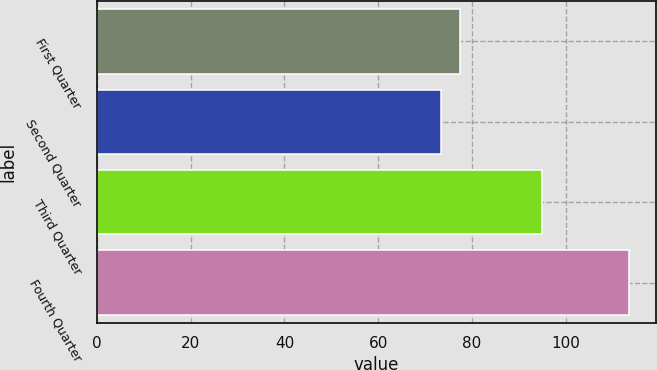Convert chart to OTSL. <chart><loc_0><loc_0><loc_500><loc_500><bar_chart><fcel>First Quarter<fcel>Second Quarter<fcel>Third Quarter<fcel>Fourth Quarter<nl><fcel>77.39<fcel>73.38<fcel>94.93<fcel>113.5<nl></chart> 